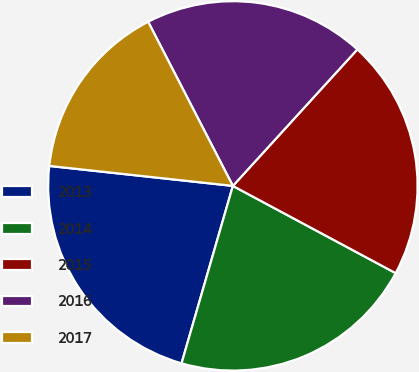<chart> <loc_0><loc_0><loc_500><loc_500><pie_chart><fcel>2013<fcel>2014<fcel>2015<fcel>2016<fcel>2017<nl><fcel>22.24%<fcel>21.65%<fcel>21.06%<fcel>19.35%<fcel>15.69%<nl></chart> 